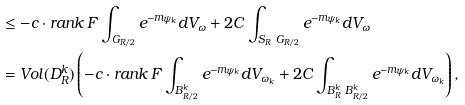Convert formula to latex. <formula><loc_0><loc_0><loc_500><loc_500>& \leq - c \cdot r a n k \, F \int _ { G _ { R / 2 } } e ^ { - m \psi _ { k } } d V _ { \omega } + 2 C \int _ { S _ { R } \ G _ { R / 2 } } e ^ { - m \psi _ { k } } d V _ { \omega } \\ & = V o l ( D ^ { k } _ { R } ) \left ( - c \cdot r a n k \, F \int _ { B ^ { k } _ { R / 2 } } e ^ { - m \psi _ { k } } d V _ { \omega _ { k } } + 2 C \int _ { B ^ { k } _ { R } \ B ^ { k } _ { R / 2 } } e ^ { - m \psi _ { k } } d V _ { \omega _ { k } } \right ) ,</formula> 